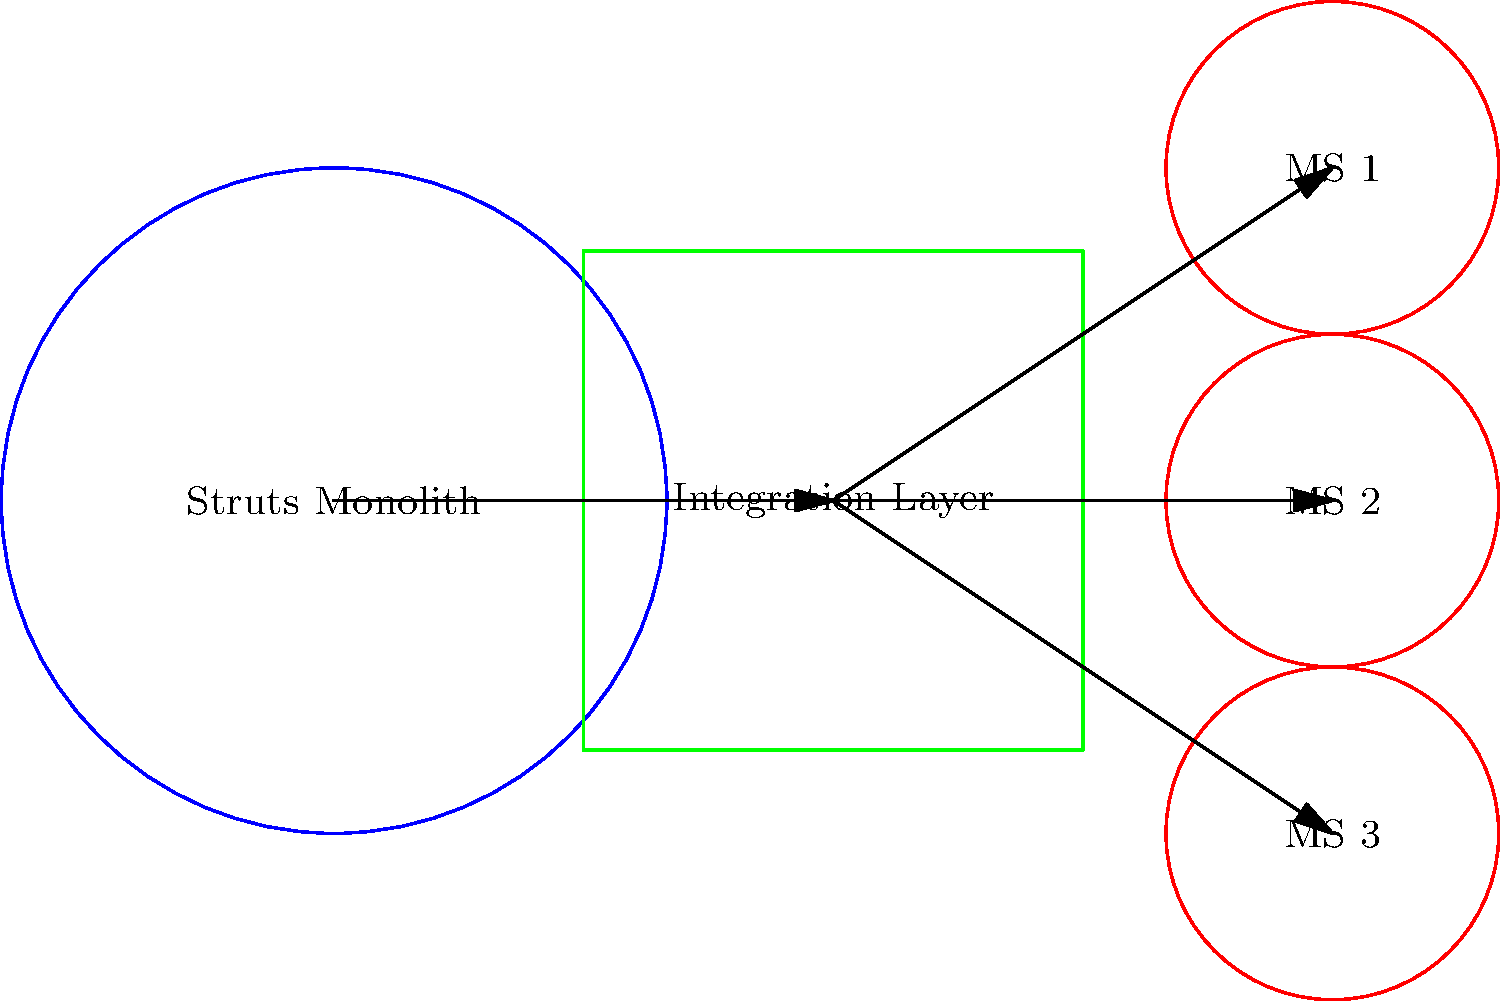In the component diagram shown, which architectural pattern is being used to integrate microservices with the existing Struts-based monolithic application, and what are the primary benefits of this approach for an e-commerce platform? To answer this question, let's analyze the diagram and consider the implications for an e-commerce platform:

1. The diagram shows a Struts Monolith (blue circle) connected to an Integration Layer (green box).
2. The Integration Layer is then connected to multiple Microservices (MS 1, MS 2, MS 3 - red circles).
3. This architecture represents the Strangler Fig Pattern, where microservices are gradually integrated with a legacy monolithic application.

The benefits of this approach for an e-commerce platform are:

1. Gradual Migration: The company can incrementally move functionality from the monolith to microservices without a complete rewrite.
2. Risk Mitigation: By moving one service at a time, the risk of system-wide failures is reduced.
3. Improved Scalability: Microservices can be independently scaled to handle varying loads, which is crucial for e-commerce platforms with fluctuating traffic.
4. Enhanced Flexibility: New features can be added as microservices without modifying the entire monolith.
5. Technology Diversity: Different microservices can use different technologies, allowing for modernization where needed.
6. Easier Maintenance: Smaller, decoupled services are easier to maintain and update than a large monolithic application.

The Integration Layer acts as a facade or API gateway, routing requests between the monolith and microservices, ensuring seamless operation during and after the migration process.
Answer: Strangler Fig Pattern 